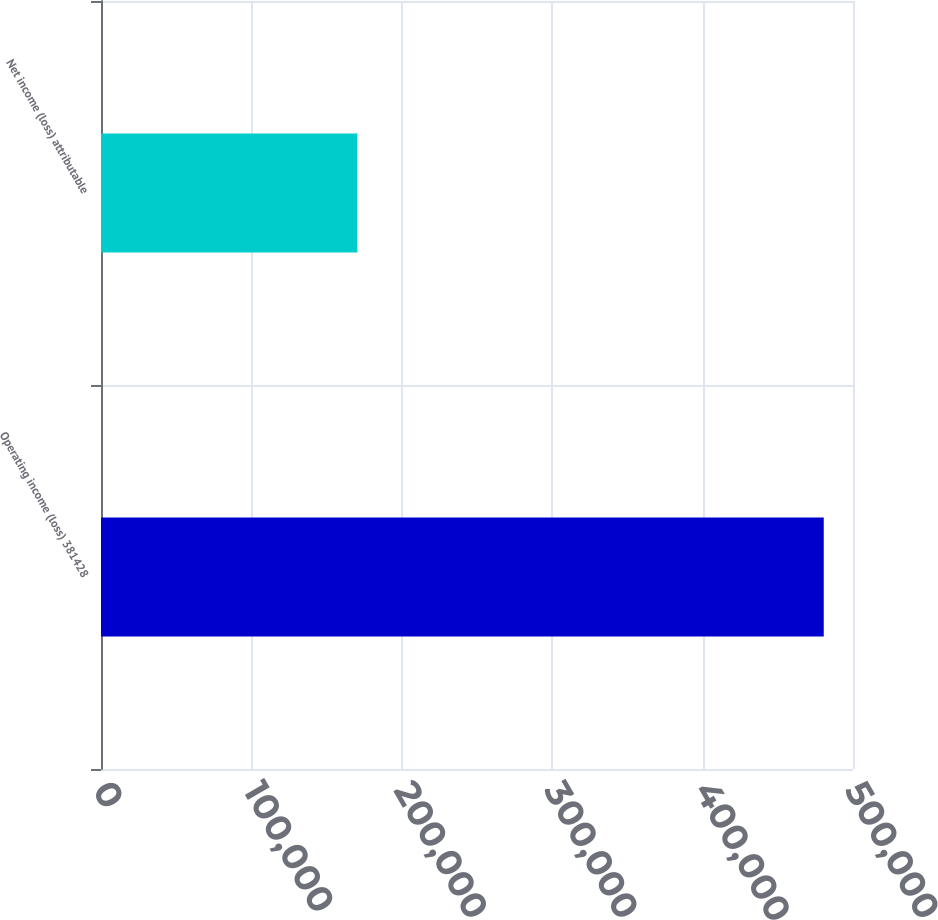Convert chart to OTSL. <chart><loc_0><loc_0><loc_500><loc_500><bar_chart><fcel>Operating income (loss) 381428<fcel>Net income (loss) attributable<nl><fcel>480548<fcel>170477<nl></chart> 